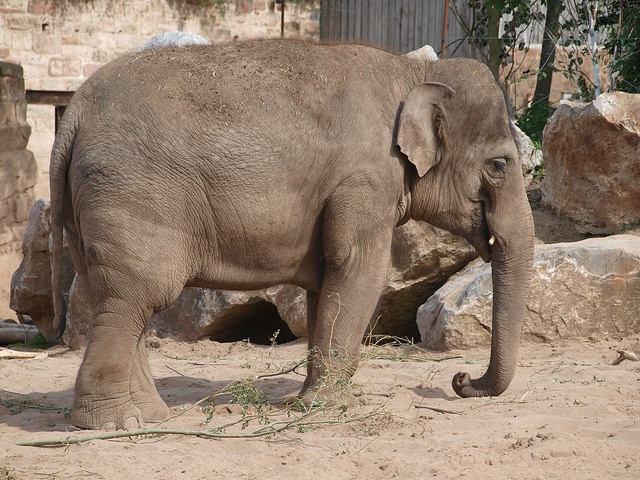Describe the objects in this image and their specific colors. I can see a elephant in tan and gray tones in this image. 